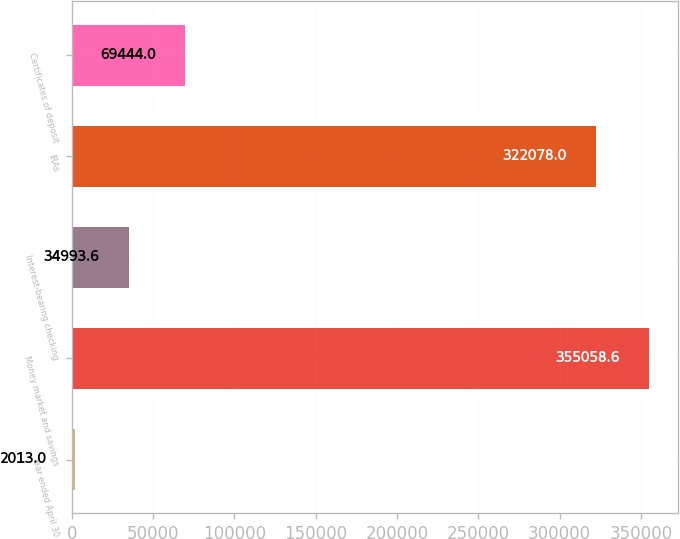Convert chart to OTSL. <chart><loc_0><loc_0><loc_500><loc_500><bar_chart><fcel>Year ended April 30<fcel>Money market and savings<fcel>Interest-bearing checking<fcel>IRAs<fcel>Certificates of deposit<nl><fcel>2013<fcel>355059<fcel>34993.6<fcel>322078<fcel>69444<nl></chart> 